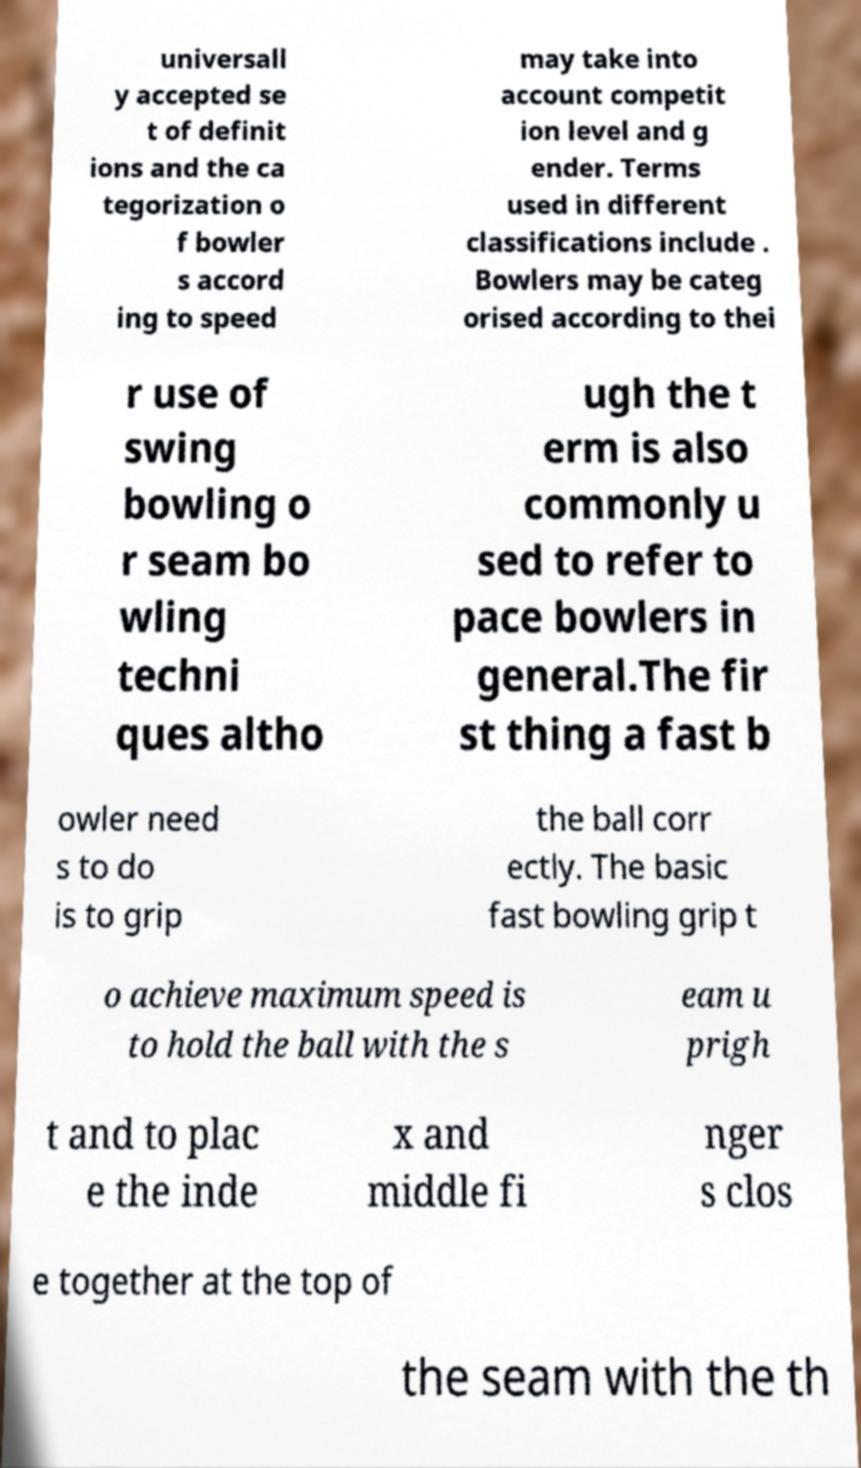Can you accurately transcribe the text from the provided image for me? universall y accepted se t of definit ions and the ca tegorization o f bowler s accord ing to speed may take into account competit ion level and g ender. Terms used in different classifications include . Bowlers may be categ orised according to thei r use of swing bowling o r seam bo wling techni ques altho ugh the t erm is also commonly u sed to refer to pace bowlers in general.The fir st thing a fast b owler need s to do is to grip the ball corr ectly. The basic fast bowling grip t o achieve maximum speed is to hold the ball with the s eam u prigh t and to plac e the inde x and middle fi nger s clos e together at the top of the seam with the th 